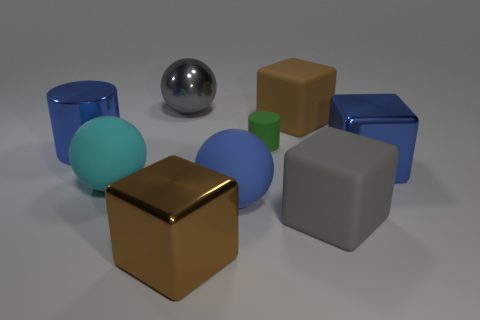There is a large rubber object that is in front of the rubber cylinder and on the right side of the green rubber object; what is its color?
Offer a terse response. Gray. Is there a large blue matte thing that has the same shape as the big cyan matte thing?
Your answer should be compact. Yes. Is the tiny rubber thing the same color as the big cylinder?
Your answer should be compact. No. Is there a large brown matte cube that is behind the cylinder on the left side of the cyan object?
Make the answer very short. Yes. How many things are either matte cubes behind the large blue rubber object or large blue metallic objects on the left side of the cyan thing?
Your answer should be compact. 2. What number of things are either large gray shiny spheres or things in front of the blue metal cylinder?
Your response must be concise. 6. There is a gray thing left of the brown thing that is behind the big brown thing that is left of the tiny matte cylinder; what size is it?
Offer a terse response. Large. There is a cylinder that is the same size as the cyan thing; what is it made of?
Your answer should be very brief. Metal. Are there any matte objects that have the same size as the brown metal thing?
Make the answer very short. Yes. Does the rubber ball that is to the right of the brown metallic object have the same size as the green rubber cylinder?
Provide a short and direct response. No. 